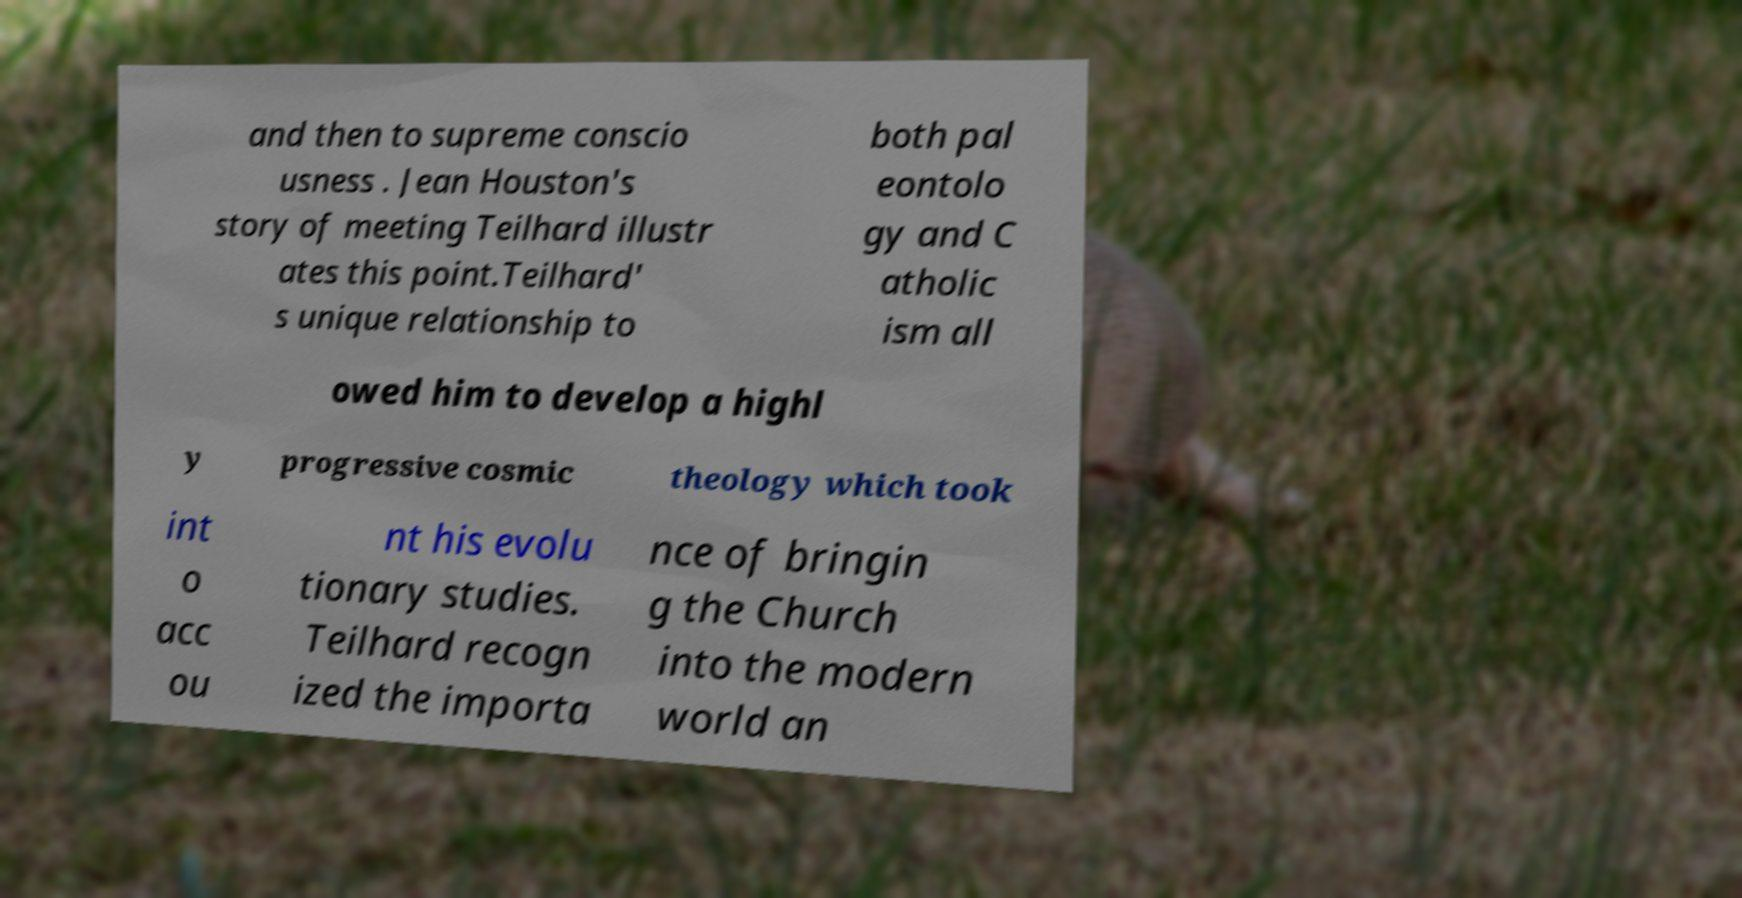What messages or text are displayed in this image? I need them in a readable, typed format. and then to supreme conscio usness . Jean Houston's story of meeting Teilhard illustr ates this point.Teilhard' s unique relationship to both pal eontolo gy and C atholic ism all owed him to develop a highl y progressive cosmic theology which took int o acc ou nt his evolu tionary studies. Teilhard recogn ized the importa nce of bringin g the Church into the modern world an 